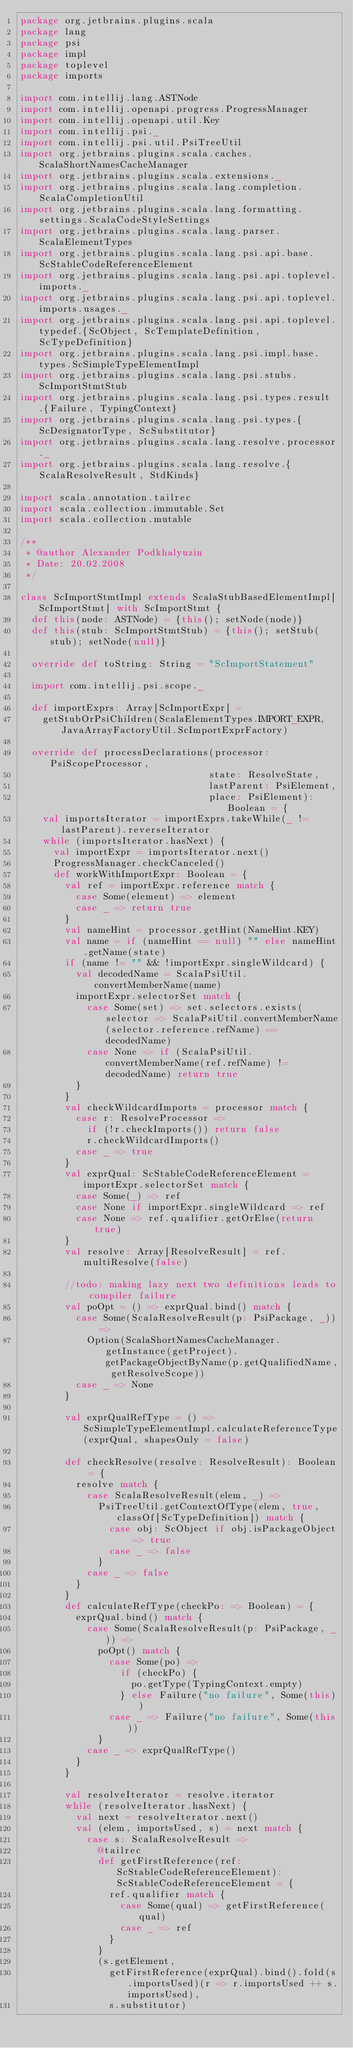Convert code to text. <code><loc_0><loc_0><loc_500><loc_500><_Scala_>package org.jetbrains.plugins.scala
package lang
package psi
package impl
package toplevel
package imports

import com.intellij.lang.ASTNode
import com.intellij.openapi.progress.ProgressManager
import com.intellij.openapi.util.Key
import com.intellij.psi._
import com.intellij.psi.util.PsiTreeUtil
import org.jetbrains.plugins.scala.caches.ScalaShortNamesCacheManager
import org.jetbrains.plugins.scala.extensions._
import org.jetbrains.plugins.scala.lang.completion.ScalaCompletionUtil
import org.jetbrains.plugins.scala.lang.formatting.settings.ScalaCodeStyleSettings
import org.jetbrains.plugins.scala.lang.parser.ScalaElementTypes
import org.jetbrains.plugins.scala.lang.psi.api.base.ScStableCodeReferenceElement
import org.jetbrains.plugins.scala.lang.psi.api.toplevel.imports._
import org.jetbrains.plugins.scala.lang.psi.api.toplevel.imports.usages._
import org.jetbrains.plugins.scala.lang.psi.api.toplevel.typedef.{ScObject, ScTemplateDefinition, ScTypeDefinition}
import org.jetbrains.plugins.scala.lang.psi.impl.base.types.ScSimpleTypeElementImpl
import org.jetbrains.plugins.scala.lang.psi.stubs.ScImportStmtStub
import org.jetbrains.plugins.scala.lang.psi.types.result.{Failure, TypingContext}
import org.jetbrains.plugins.scala.lang.psi.types.{ScDesignatorType, ScSubstitutor}
import org.jetbrains.plugins.scala.lang.resolve.processor._
import org.jetbrains.plugins.scala.lang.resolve.{ScalaResolveResult, StdKinds}

import scala.annotation.tailrec
import scala.collection.immutable.Set
import scala.collection.mutable

/**
 * @author Alexander Podkhalyuzin
 * Date: 20.02.2008
 */

class ScImportStmtImpl extends ScalaStubBasedElementImpl[ScImportStmt] with ScImportStmt {
  def this(node: ASTNode) = {this(); setNode(node)}
  def this(stub: ScImportStmtStub) = {this(); setStub(stub); setNode(null)}

  override def toString: String = "ScImportStatement"

  import com.intellij.psi.scope._

  def importExprs: Array[ScImportExpr] =
    getStubOrPsiChildren(ScalaElementTypes.IMPORT_EXPR, JavaArrayFactoryUtil.ScImportExprFactory)

  override def processDeclarations(processor: PsiScopeProcessor,
                                  state: ResolveState,
                                  lastParent: PsiElement,
                                  place: PsiElement): Boolean = {
    val importsIterator = importExprs.takeWhile(_ != lastParent).reverseIterator
    while (importsIterator.hasNext) {
      val importExpr = importsIterator.next()
      ProgressManager.checkCanceled()
      def workWithImportExpr: Boolean = {
        val ref = importExpr.reference match {
          case Some(element) => element
          case _ => return true
        }
        val nameHint = processor.getHint(NameHint.KEY)
        val name = if (nameHint == null) "" else nameHint.getName(state)
        if (name != "" && !importExpr.singleWildcard) {
          val decodedName = ScalaPsiUtil.convertMemberName(name)
          importExpr.selectorSet match {
            case Some(set) => set.selectors.exists(selector => ScalaPsiUtil.convertMemberName(selector.reference.refName) == decodedName)
            case None => if (ScalaPsiUtil.convertMemberName(ref.refName) != decodedName) return true
          }
        }
        val checkWildcardImports = processor match {
          case r: ResolveProcessor =>
            if (!r.checkImports()) return false
            r.checkWildcardImports()
          case _ => true
        }
        val exprQual: ScStableCodeReferenceElement = importExpr.selectorSet match {
          case Some(_) => ref
          case None if importExpr.singleWildcard => ref
          case None => ref.qualifier.getOrElse(return true)
        }
        val resolve: Array[ResolveResult] = ref.multiResolve(false)

        //todo: making lazy next two definitions leads to compiler failure
        val poOpt = () => exprQual.bind() match {
          case Some(ScalaResolveResult(p: PsiPackage, _)) =>
            Option(ScalaShortNamesCacheManager.getInstance(getProject).getPackageObjectByName(p.getQualifiedName, getResolveScope))
          case _ => None
        }

        val exprQualRefType = () => ScSimpleTypeElementImpl.calculateReferenceType(exprQual, shapesOnly = false)

        def checkResolve(resolve: ResolveResult): Boolean = {
          resolve match {
            case ScalaResolveResult(elem, _) =>
              PsiTreeUtil.getContextOfType(elem, true, classOf[ScTypeDefinition]) match {
                case obj: ScObject if obj.isPackageObject => true
                case _ => false
              }
            case _ => false
          }
        }
        def calculateRefType(checkPo: => Boolean) = {
          exprQual.bind() match {
            case Some(ScalaResolveResult(p: PsiPackage, _)) =>
              poOpt() match {
                case Some(po) =>
                  if (checkPo) {
                    po.getType(TypingContext.empty)
                  } else Failure("no failure", Some(this))
                case _ => Failure("no failure", Some(this))
              }
            case _ => exprQualRefType()
          }
        }

        val resolveIterator = resolve.iterator
        while (resolveIterator.hasNext) {
          val next = resolveIterator.next()
          val (elem, importsUsed, s) = next match {
            case s: ScalaResolveResult =>
              @tailrec
              def getFirstReference(ref: ScStableCodeReferenceElement): ScStableCodeReferenceElement = {
                ref.qualifier match {
                  case Some(qual) => getFirstReference(qual)
                  case _ => ref
                }
              }
              (s.getElement,
                getFirstReference(exprQual).bind().fold(s.importsUsed)(r => r.importsUsed ++ s.importsUsed),
                s.substitutor)</code> 